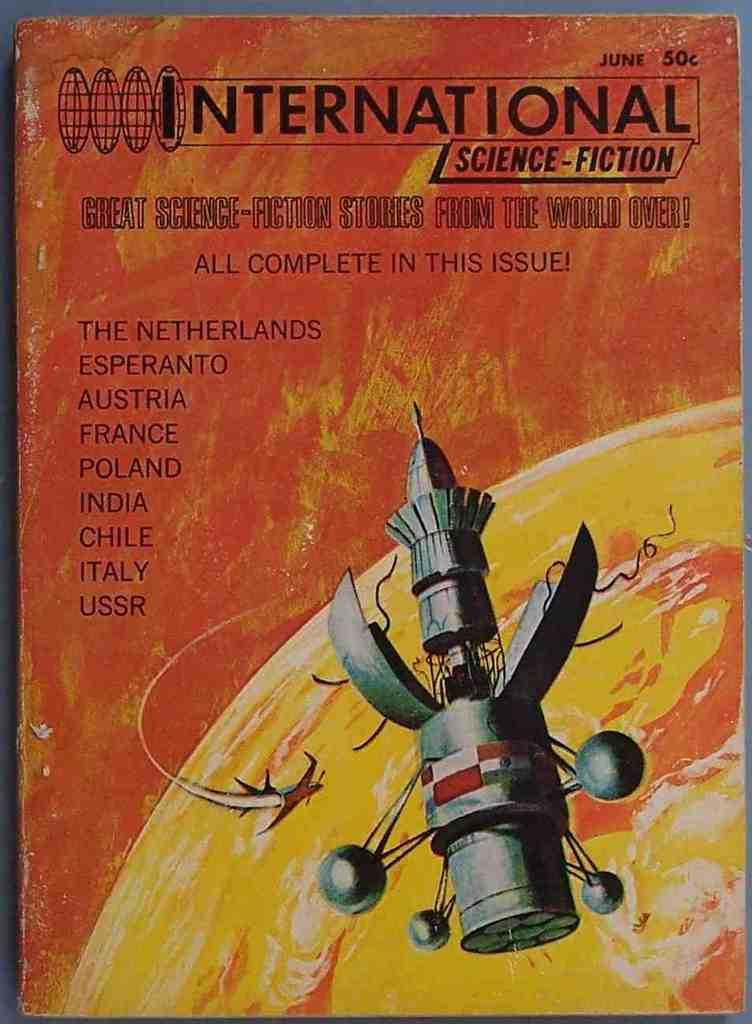Provide a one-sentence caption for the provided image. A poster for International Science-Fiction and a sattelite on it. 